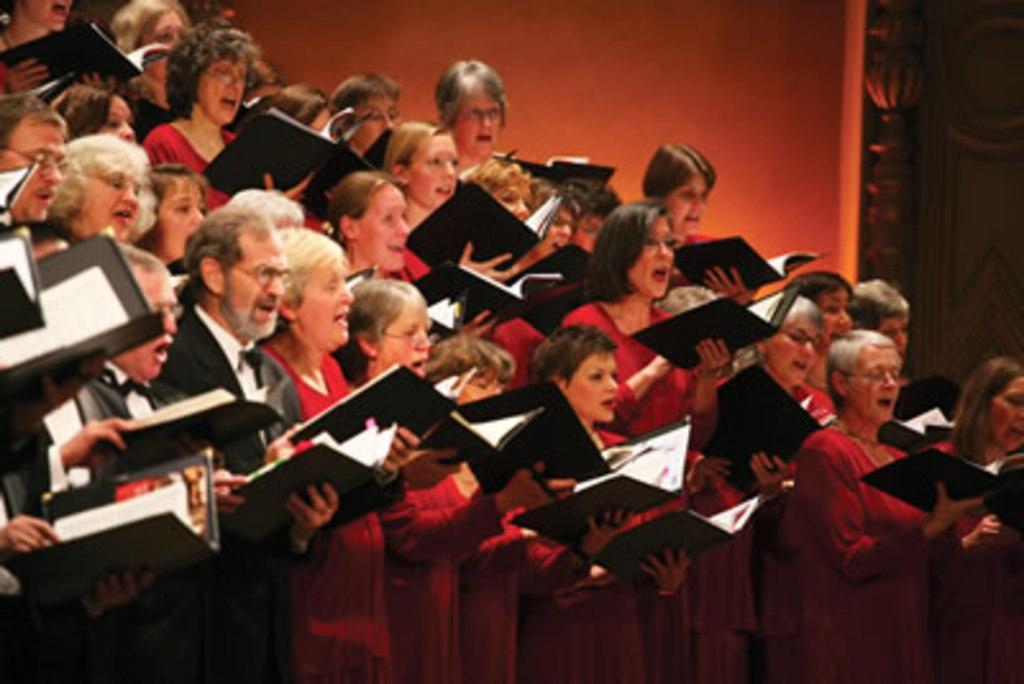How would you summarize this image in a sentence or two? In this image in front there are few people standing by holding the books. Behind them there is a wall. Beside the wall there is a door. 